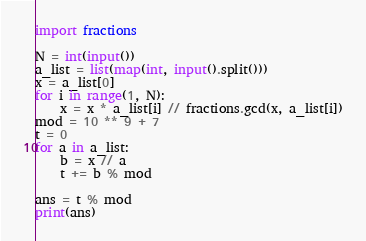<code> <loc_0><loc_0><loc_500><loc_500><_Python_>import fractions

N = int(input())
a_list = list(map(int, input().split()))
x = a_list[0]
for i in range(1, N):
    x = x * a_list[i] // fractions.gcd(x, a_list[i])
mod = 10 ** 9 + 7
t = 0
for a in a_list:
    b = x // a
    t += b % mod

ans = t % mod
print(ans)</code> 